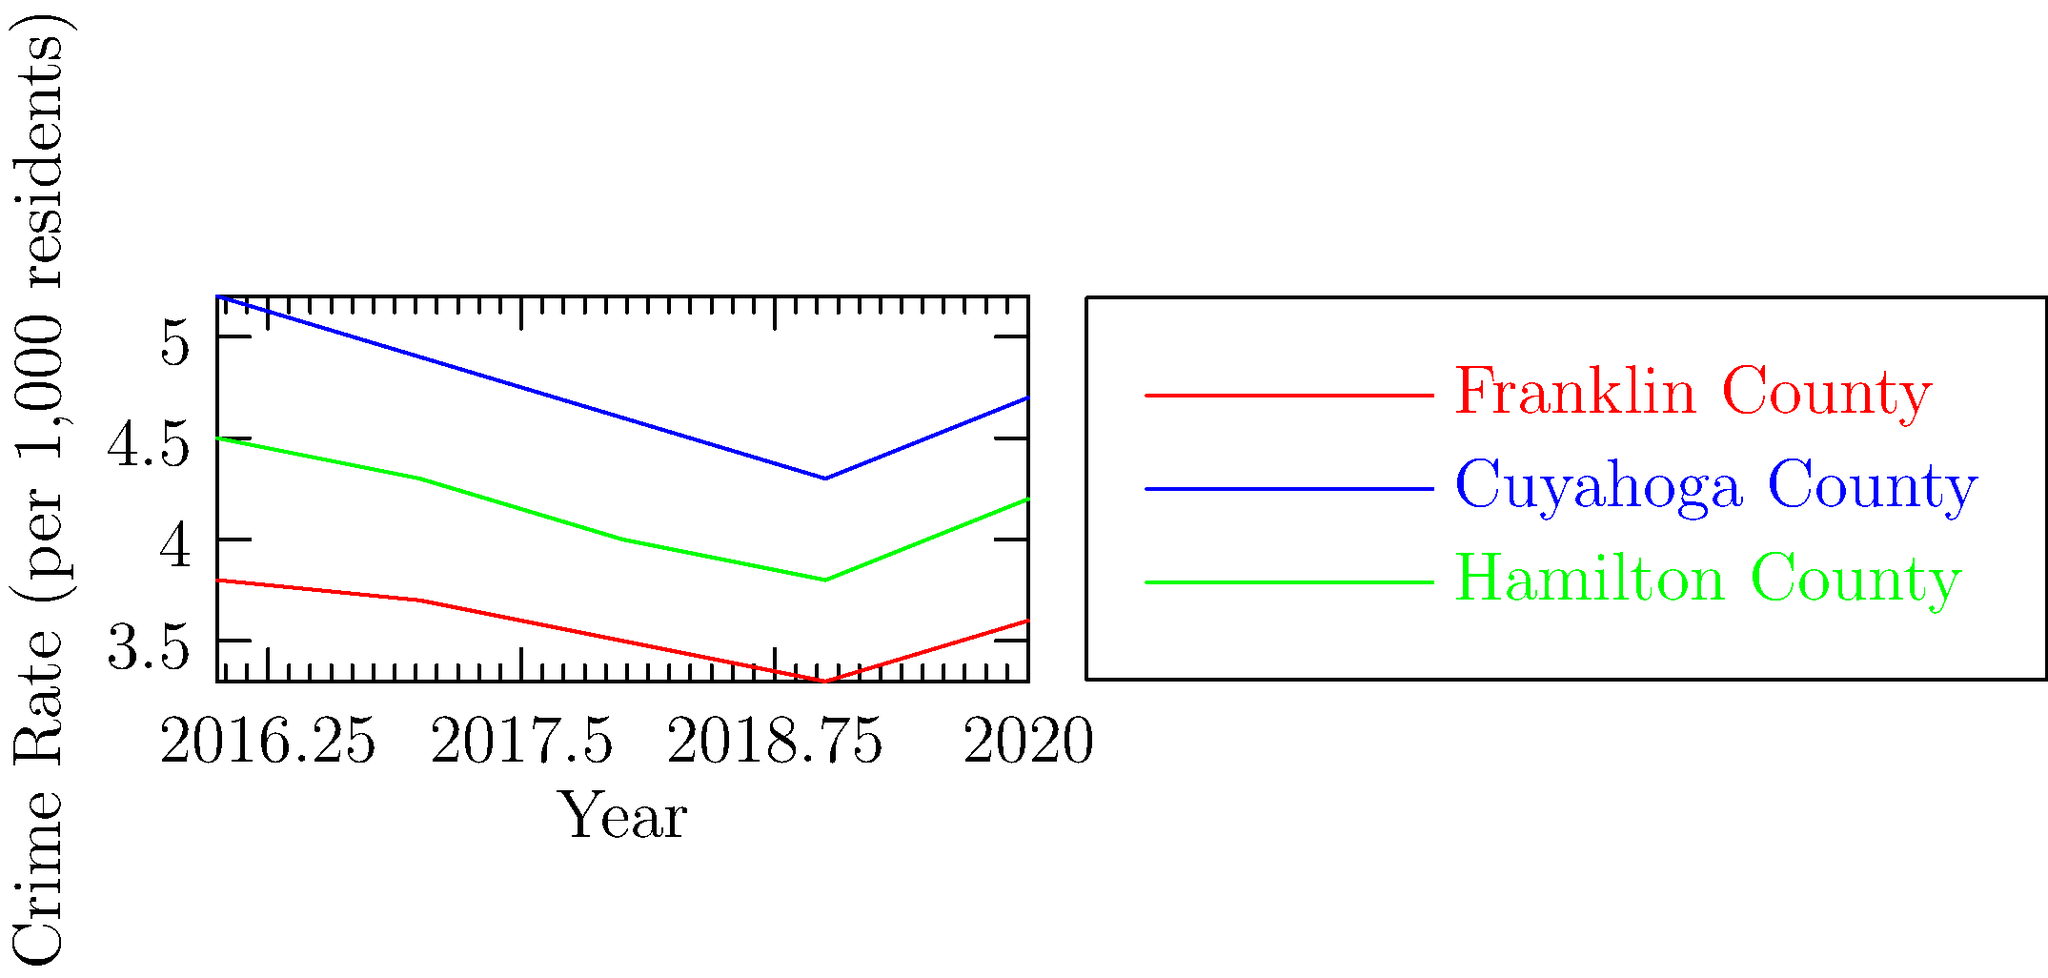Based on the line graph showing crime rate trends in three Ohio counties from 2016 to 2020, which county consistently maintained the highest crime rate throughout the entire period, and what was its lowest recorded rate? To answer this question, we need to analyze the crime rate trends for each county:

1. Identify the lines:
   - Red line: Franklin County
   - Blue line: Cuyahoga County
   - Green line: Hamilton County

2. Compare the lines:
   - The blue line (Cuyahoga County) is consistently higher than the other two lines for all years.

3. Identify Cuyahoga County's lowest point:
   - 2016: 5.2
   - 2017: 4.9
   - 2018: 4.6
   - 2019: 4.3
   - 2020: 4.7

The lowest point for Cuyahoga County is in 2019 at 4.3 per 1,000 residents.
Answer: Cuyahoga County; 4.3 per 1,000 residents 